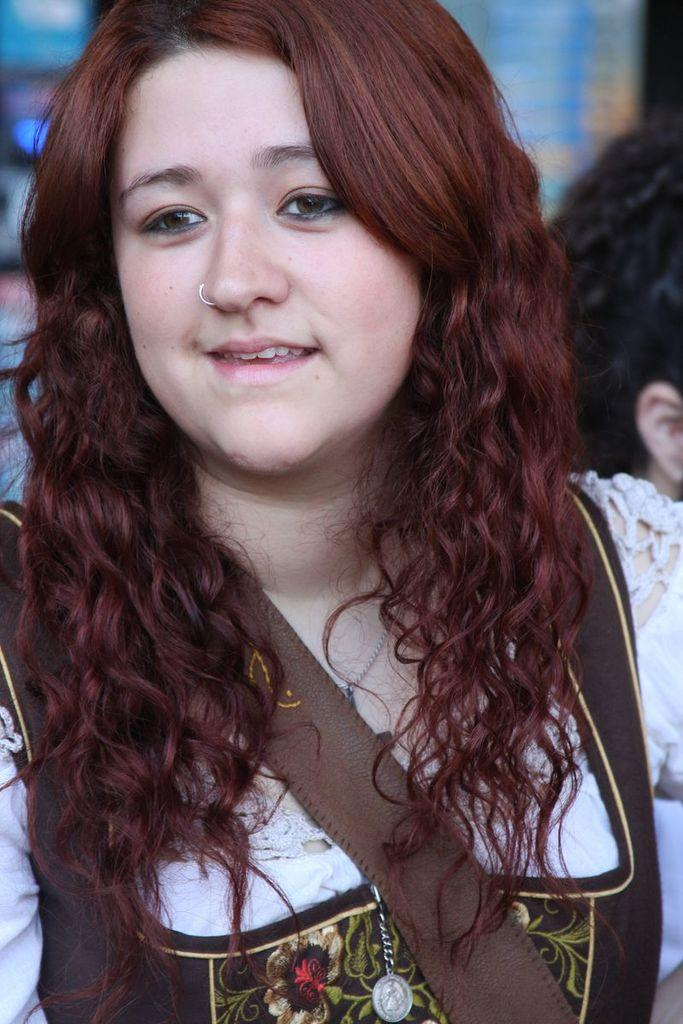What is the main subject of the image? There is a beautiful girl in the image. What is the girl's expression in the image? The girl is smiling in the image. What is the girl wearing in the image? The girl is wearing a white dress in the image. What type of wristwatch is the girl wearing in the image? There is no wristwatch visible in the image. Can you see any zebras in the background of the image? There are no zebras present in the image. 